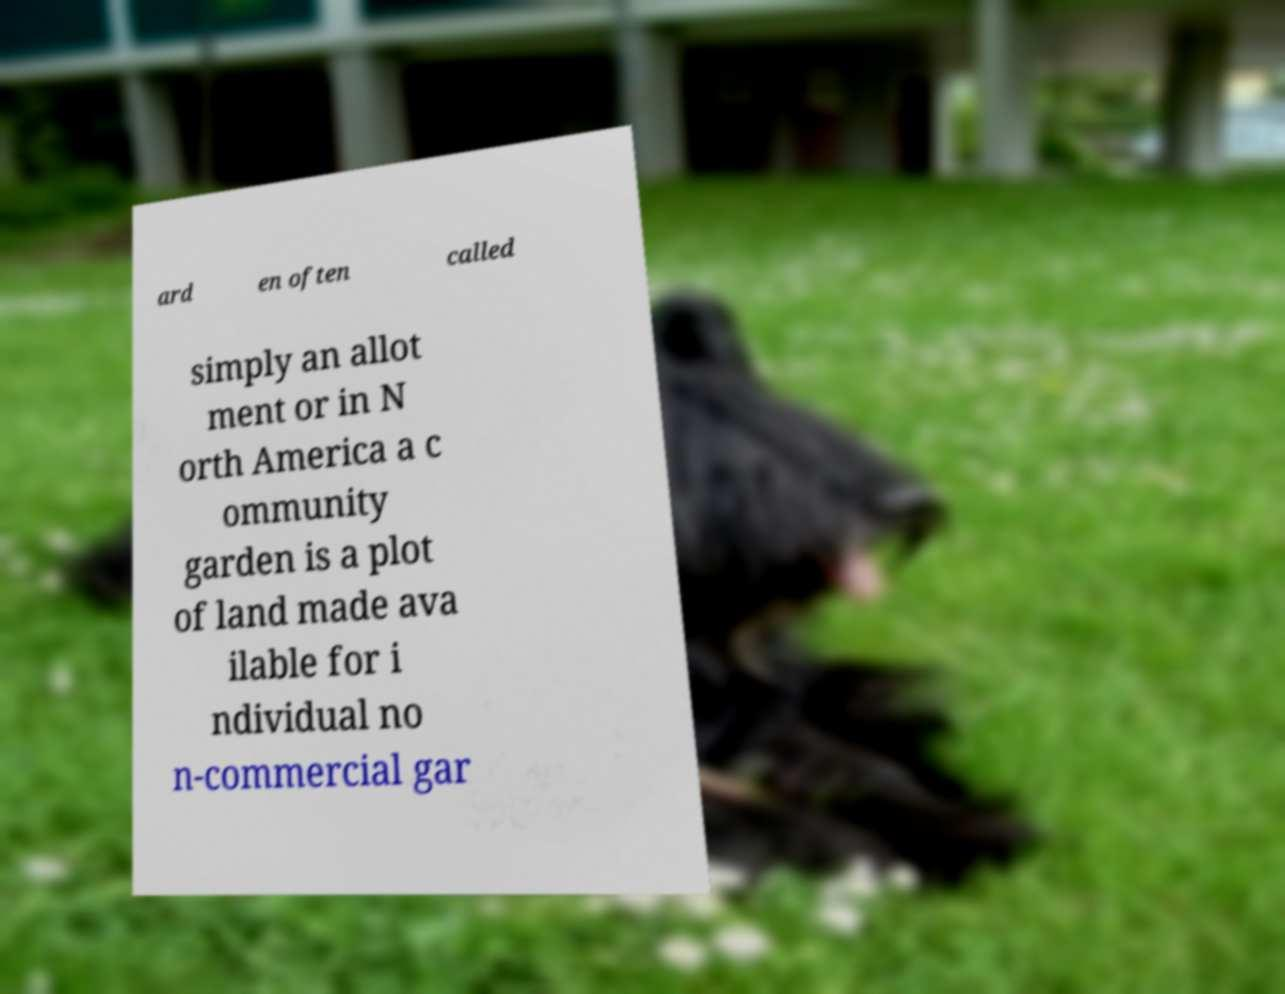There's text embedded in this image that I need extracted. Can you transcribe it verbatim? ard en often called simply an allot ment or in N orth America a c ommunity garden is a plot of land made ava ilable for i ndividual no n-commercial gar 